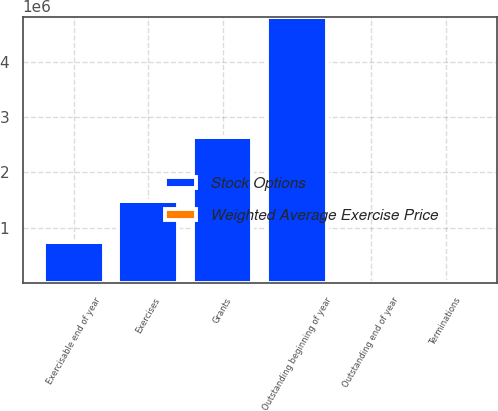Convert chart. <chart><loc_0><loc_0><loc_500><loc_500><stacked_bar_chart><ecel><fcel>Outstanding beginning of year<fcel>Grants<fcel>Terminations<fcel>Exercises<fcel>Outstanding end of year<fcel>Exercisable end of year<nl><fcel>Stock Options<fcel>4.82735e+06<fcel>2.636e+06<fcel>19250<fcel>1.47795e+06<fcel>28.36<fcel>745336<nl><fcel>Weighted Average Exercise Price<fcel>15.98<fcel>28.36<fcel>22.74<fcel>12.27<fcel>20.01<fcel>12.96<nl></chart> 